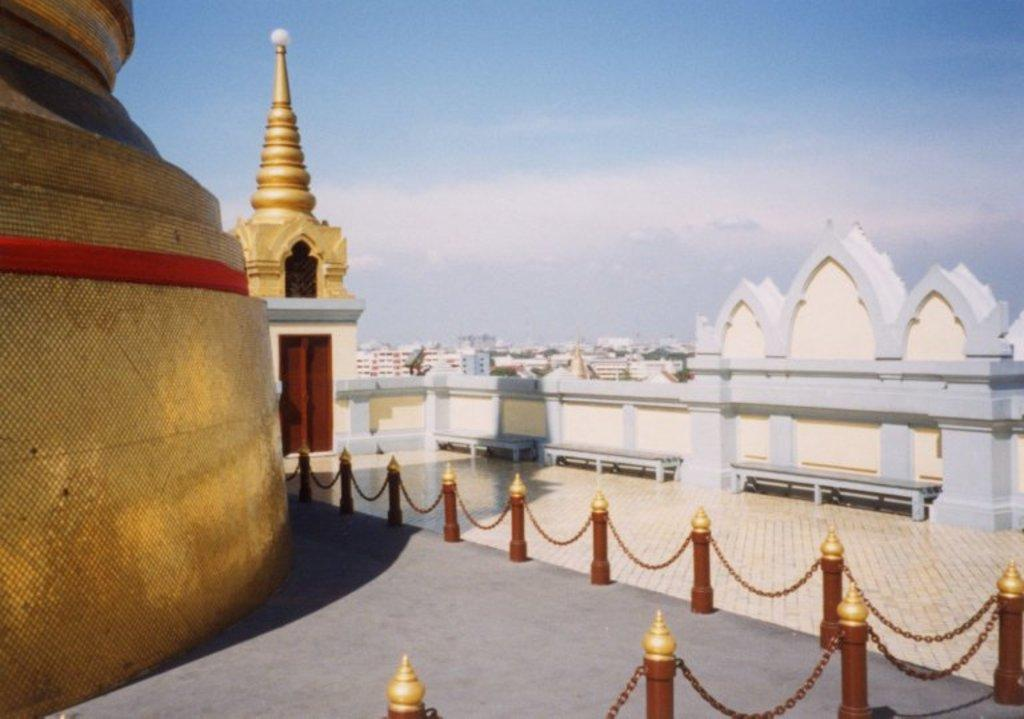What type of architectural feature is shown in the image? The image depicts a terrace of some architecture. What can be seen in the distance behind the terrace? There are many buildings visible in the background of the image. What type of face can be seen on the terrace in the image? There is no face visible on the terrace in the image. What type of underwear is hanging on the terrace in the image? There is no underwear visible on the terrace in the image. 